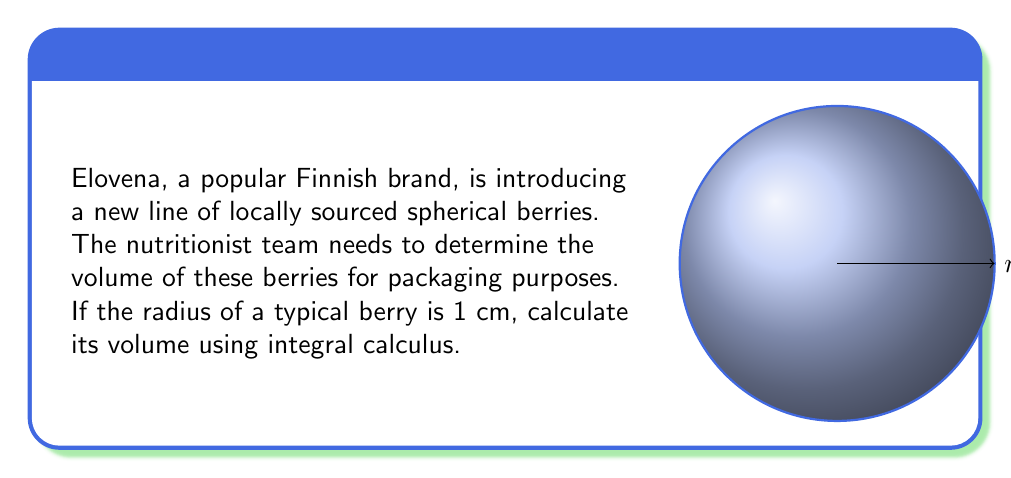Can you answer this question? To calculate the volume of a sphere using integral calculus, we'll use the method of cylindrical shells:

1) First, we set up the integral. The volume of a cylindrical shell is given by $2\pi x y dx$, where $x$ is the radius of the shell and $y$ is its height.

2) In a sphere of radius $r$, the relationship between $x$ and $y$ is given by the Pythagorean theorem:
   $x^2 + y^2 = r^2$
   Solving for $y$: $y = \sqrt{r^2 - x^2}$

3) The volume of the sphere is then:
   $$V = 2\pi \int_0^r x\sqrt{r^2 - x^2} dx$$

4) To solve this integral, we use the substitution $x = r\sin\theta$:
   $dx = r\cos\theta d\theta$
   When $x = 0$, $\theta = 0$
   When $x = r$, $\theta = \frac{\pi}{2}$

5) Substituting:
   $$V = 2\pi \int_0^{\frac{\pi}{2}} (r\sin\theta)(r\cos\theta)(r\cos\theta) d\theta$$
   $$= 2\pi r^3 \int_0^{\frac{\pi}{2}} \sin\theta \cos^2\theta d\theta$$

6) This integral can be solved using the identity $\cos^2\theta = \frac{1 + \cos(2\theta)}{2}$:
   $$V = \pi r^3 \int_0^{\frac{\pi}{2}} \sin\theta (1 + \cos(2\theta)) d\theta$$
   $$= \pi r^3 \left[-\cos\theta - \frac{1}{4}\cos(2\theta)\right]_0^{\frac{\pi}{2}}$$
   $$= \pi r^3 \left(1 + \frac{1}{4}\right)$$
   $$= \frac{4}{3}\pi r^3$$

7) For $r = 1$ cm:
   $$V = \frac{4}{3}\pi (1)^3 = \frac{4}{3}\pi \text{ cm}^3$$
Answer: $\frac{4}{3}\pi \text{ cm}^3$ 